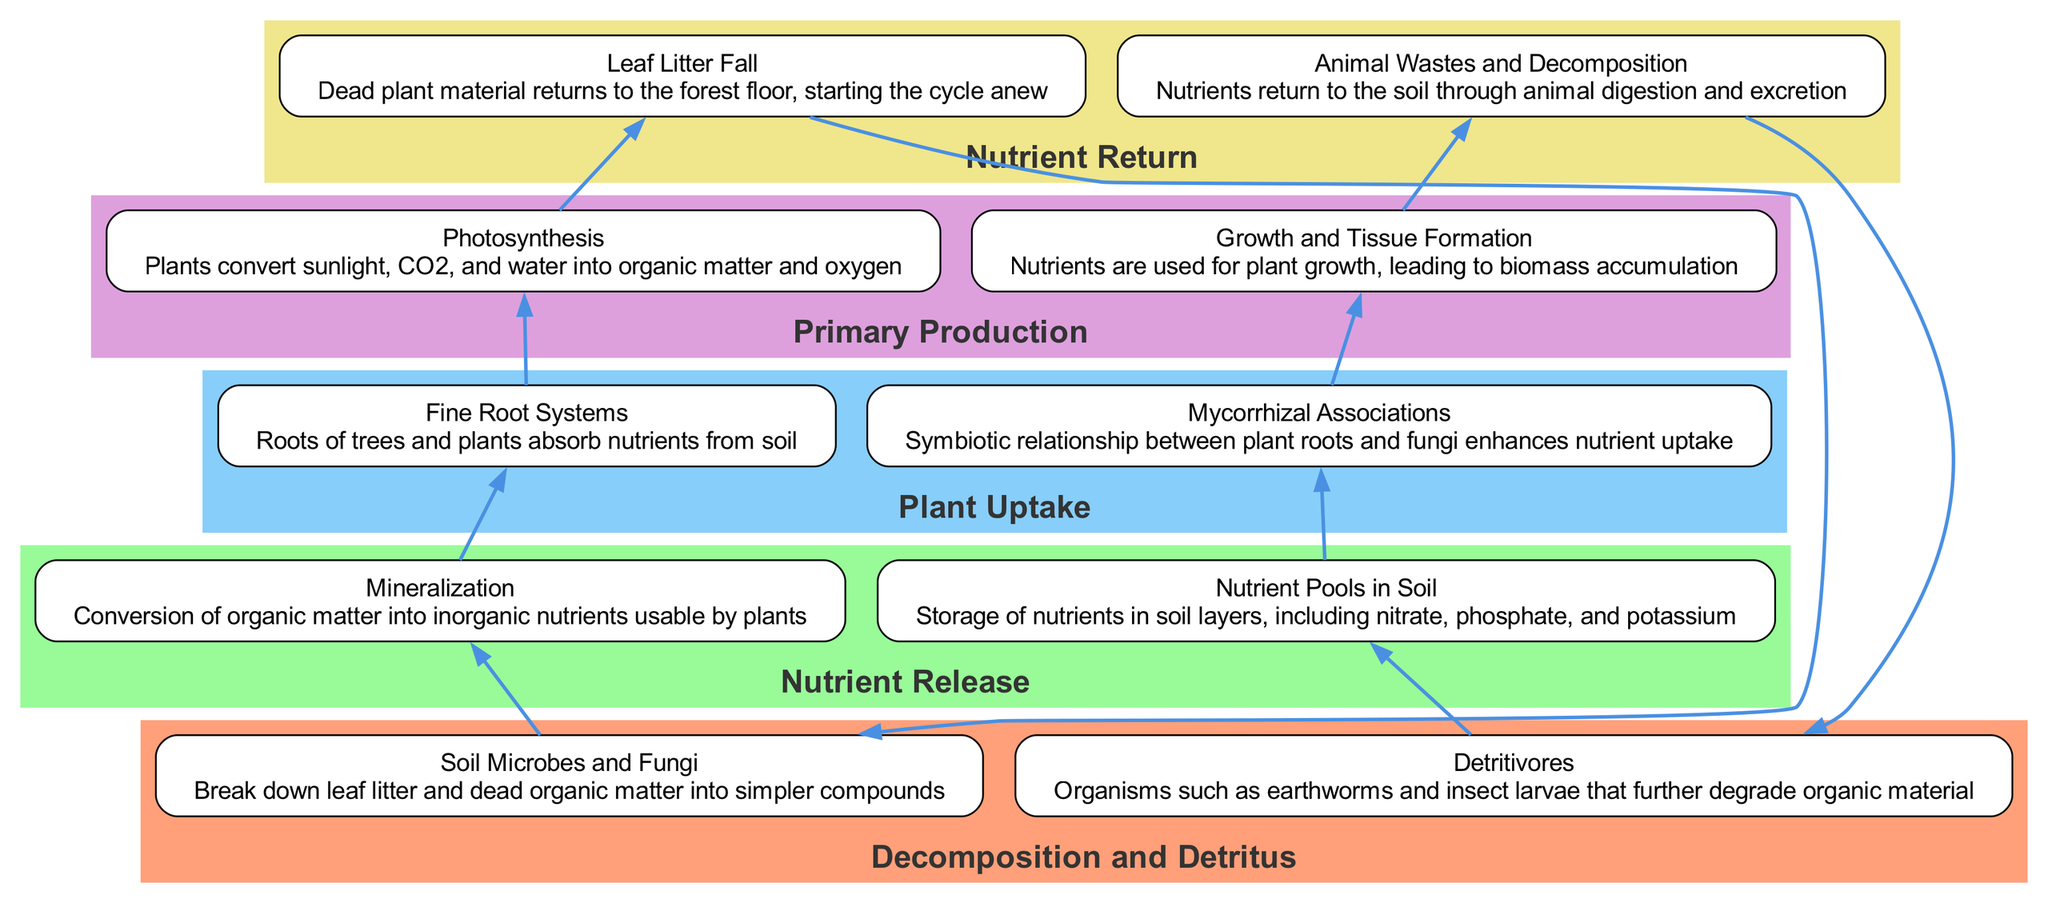What are the two components of Decomposition and Detritus? The diagram shows that the components of Decomposition and Detritus are "Soil Microbes and Fungi" and "Detritivores".
Answer: Soil Microbes and Fungi, Detritivores What is the process that converts organic matter into inorganic nutrients? According to the diagram, "Mineralization" is identified as the conversion of organic matter into inorganic nutrients that are usable by plants.
Answer: Mineralization How many processes are shown in the diagram? The diagram lists five main processes: Decomposition and Detritus, Nutrient Release, Plant Uptake, Primary Production, and Nutrient Return. Counting them gives us a total of five.
Answer: 5 What is the relationship between Fine Root Systems and Photosynthesis? The diagram indicates that Fine Root Systems absorb nutrients from the soil, which then flow to Photosynthesis, representing a dependency where nutrient uptake is essential for photosynthesis.
Answer: Nutritional dependency What happens to leaf litter according to the cycle? The process outlined in the diagram states that "Leaf Litter Fall" leads to the decomposition of dead plant material, which returns nutrients to the soil, restarting the cycle.
Answer: Leaf Litter Fall returns nutrients Which component enhances nutrient uptake in plants? The diagram specifies that "Mycorrhizal Associations" are the symbiotic relationships between plant roots and fungi that enhance nutrient uptake.
Answer: Mycorrhizal Associations What starts the nutrient cycle anew? According to the diagram, "Leaf Litter Fall" initiates the nutrient cycle again by returning dead plant material to the forest floor.
Answer: Leaf Litter Fall Which process comes directly after Nutrient Pools in Soil? The diagram shows that after Nutrient Pools in Soil, the next process is Plant Uptake, indicating the sequence of nutrient availability transitioning into plant absorption.
Answer: Plant Uptake What is the primary role of Soil Microbes and Fungi? The diagram describes the primary role of Soil Microbes and Fungi as breaking down leaf litter and dead organic matter into simpler compounds.
Answer: Break down leaf litter and dead organic matter 